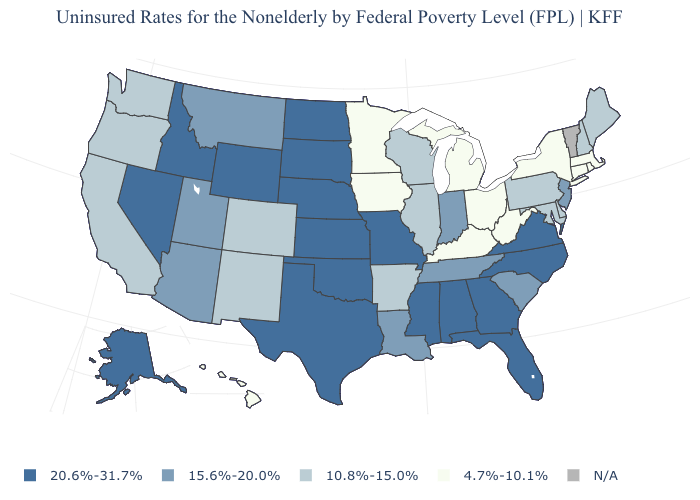What is the lowest value in the USA?
Give a very brief answer. 4.7%-10.1%. Among the states that border Virginia , which have the lowest value?
Write a very short answer. Kentucky, West Virginia. How many symbols are there in the legend?
Keep it brief. 5. Does the first symbol in the legend represent the smallest category?
Quick response, please. No. Does the map have missing data?
Concise answer only. Yes. Is the legend a continuous bar?
Answer briefly. No. How many symbols are there in the legend?
Write a very short answer. 5. Does the first symbol in the legend represent the smallest category?
Concise answer only. No. Name the states that have a value in the range 10.8%-15.0%?
Keep it brief. Arkansas, California, Colorado, Delaware, Illinois, Maine, Maryland, New Hampshire, New Mexico, Oregon, Pennsylvania, Washington, Wisconsin. Among the states that border Delaware , does New Jersey have the lowest value?
Short answer required. No. What is the lowest value in states that border Illinois?
Write a very short answer. 4.7%-10.1%. Which states have the highest value in the USA?
Short answer required. Alabama, Alaska, Florida, Georgia, Idaho, Kansas, Mississippi, Missouri, Nebraska, Nevada, North Carolina, North Dakota, Oklahoma, South Dakota, Texas, Virginia, Wyoming. 